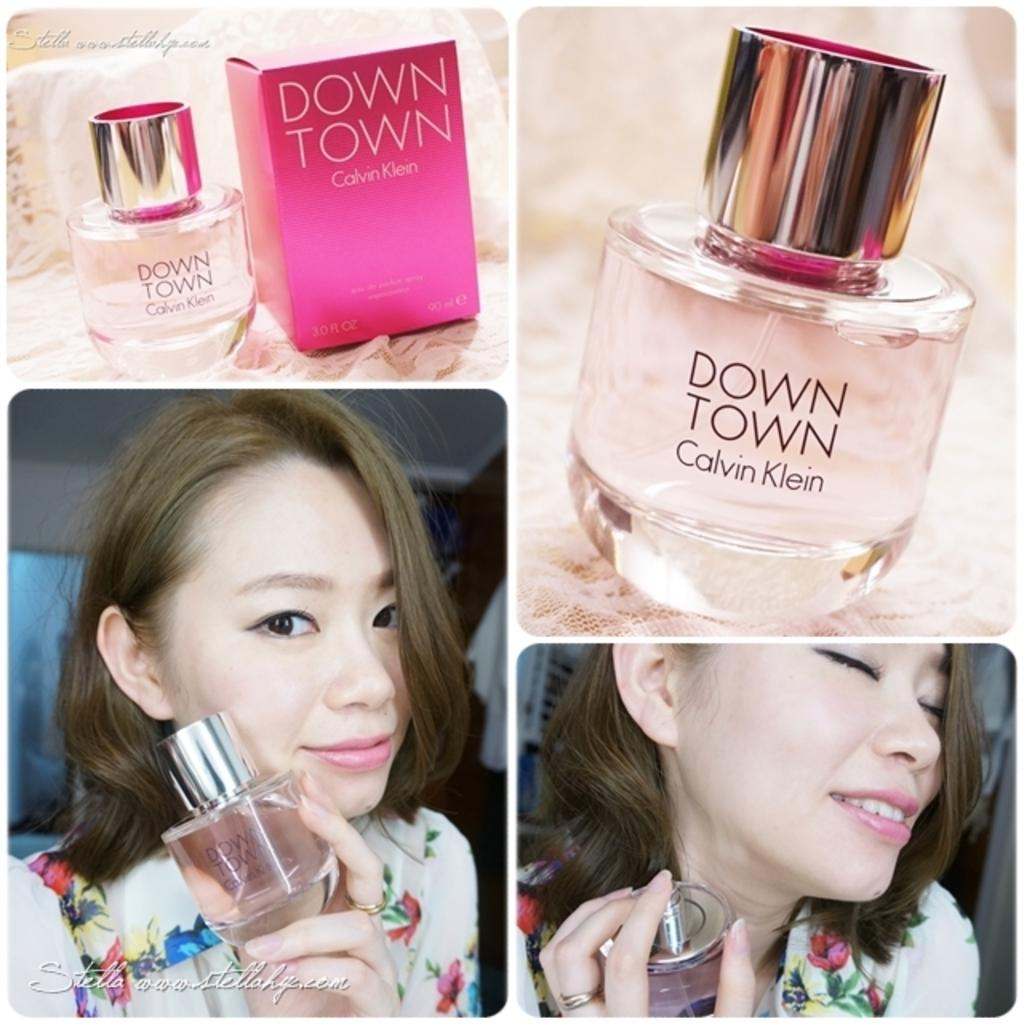<image>
Describe the image concisely. An ad for Down Town perfume featuring and asian woman. 